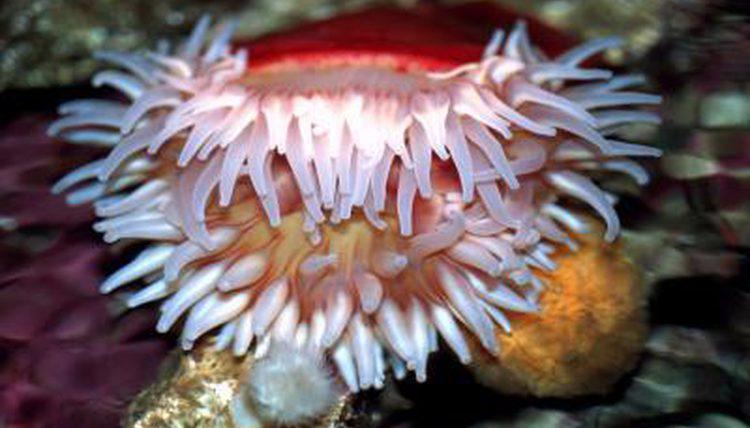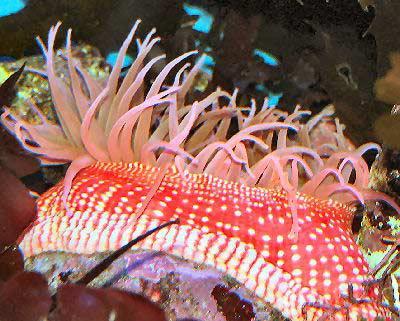The first image is the image on the left, the second image is the image on the right. Assess this claim about the two images: "Right and left images each show only one flower-shaped anemone with tendrils spreading out like petals, and the anemones do not share the same color.". Correct or not? Answer yes or no. No. The first image is the image on the left, the second image is the image on the right. Examine the images to the left and right. Is the description "There is a round anemone that is a pale peach color in the left image." accurate? Answer yes or no. Yes. 